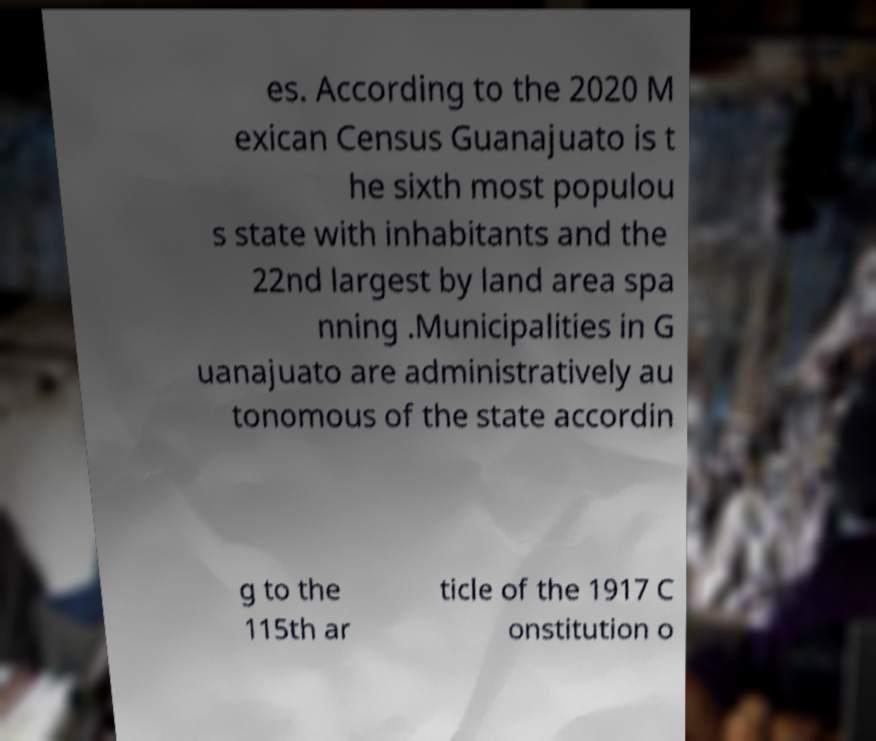Can you accurately transcribe the text from the provided image for me? es. According to the 2020 M exican Census Guanajuato is t he sixth most populou s state with inhabitants and the 22nd largest by land area spa nning .Municipalities in G uanajuato are administratively au tonomous of the state accordin g to the 115th ar ticle of the 1917 C onstitution o 